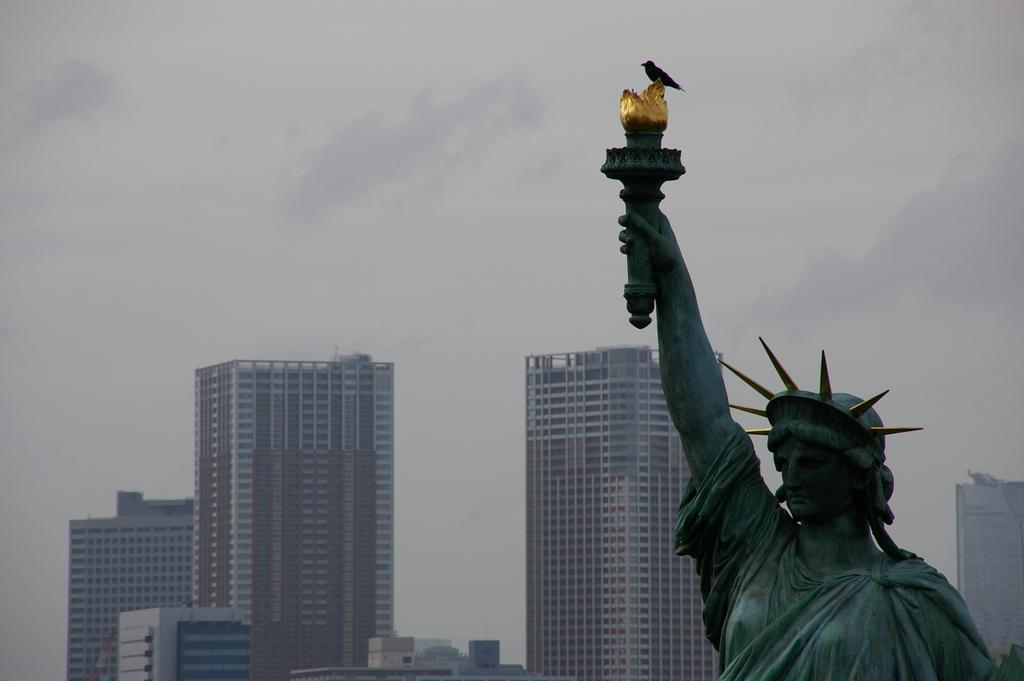What is the main subject of the image? There is a statue of the Liberty monument in the image. Where is the statue located in the image? The statue is in the right bottom of the image. What is on the statue in the image? A bird is on the monument. What can be seen in the background of the image? There are buildings in the background of the image. What is visible at the top of the image? The sky is visible at the top of the image. What type of plantation is depicted in the image? There is no plantation present in the image; it features a statue of the Liberty monument. What unit is responsible for maintaining peace in the image? There is no specific unit or organization responsible for maintaining peace in the image; it is a static representation of the Liberty monument. 